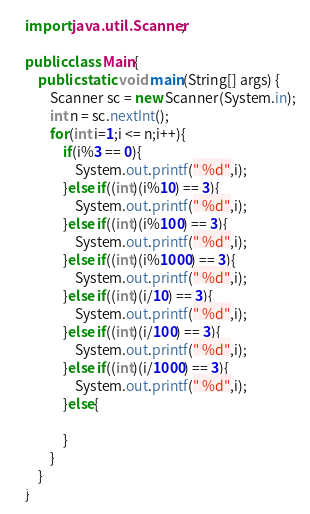<code> <loc_0><loc_0><loc_500><loc_500><_Java_>import java.util.Scanner;

public class Main{
    public static void main(String[] args) {
        Scanner sc = new Scanner(System.in);
        int n = sc.nextInt();
        for(int i=1;i <= n;i++){
            if(i%3 == 0){
                System.out.printf(" %d",i);
            }else if((int)(i%10) == 3){
                System.out.printf(" %d",i);
            }else if((int)(i%100) == 3){
                System.out.printf(" %d",i);
            }else if((int)(i%1000) == 3){
                System.out.printf(" %d",i);
            }else if((int)(i/10) == 3){
                System.out.printf(" %d",i);
            }else if((int)(i/100) == 3){
                System.out.printf(" %d",i);
            }else if((int)(i/1000) == 3){
                System.out.printf(" %d",i);
            }else{

            }
        }
    }
}
</code> 